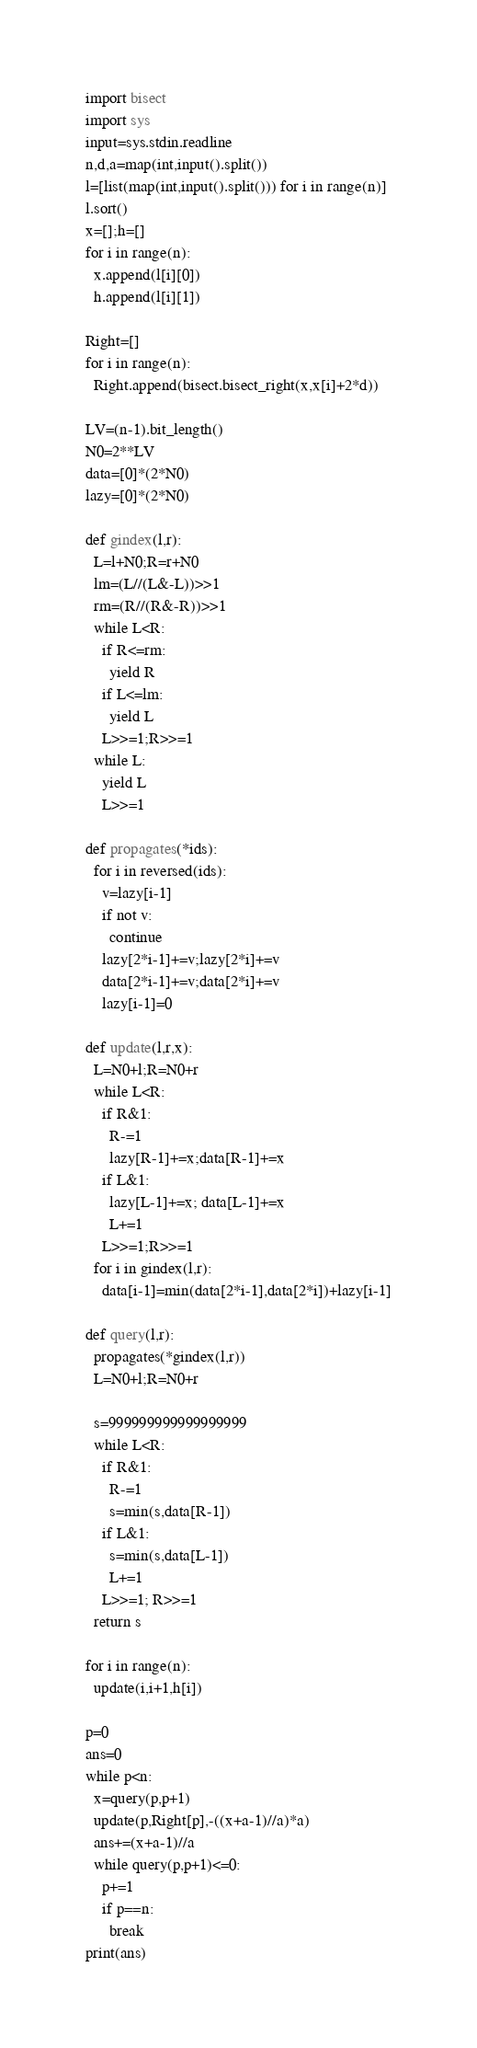<code> <loc_0><loc_0><loc_500><loc_500><_Python_>import bisect
import sys
input=sys.stdin.readline
n,d,a=map(int,input().split())
l=[list(map(int,input().split())) for i in range(n)]
l.sort()
x=[];h=[]
for i in range(n):
  x.append(l[i][0])
  h.append(l[i][1])

Right=[]
for i in range(n):
  Right.append(bisect.bisect_right(x,x[i]+2*d))

LV=(n-1).bit_length()
N0=2**LV
data=[0]*(2*N0)
lazy=[0]*(2*N0)

def gindex(l,r):
  L=l+N0;R=r+N0
  lm=(L//(L&-L))>>1
  rm=(R//(R&-R))>>1
  while L<R:
    if R<=rm:
      yield R
    if L<=lm:
      yield L
    L>>=1;R>>=1
  while L:
    yield L
    L>>=1

def propagates(*ids):
  for i in reversed(ids):
    v=lazy[i-1]
    if not v:
      continue
    lazy[2*i-1]+=v;lazy[2*i]+=v
    data[2*i-1]+=v;data[2*i]+=v
    lazy[i-1]=0

def update(l,r,x):
  L=N0+l;R=N0+r
  while L<R:
    if R&1:
      R-=1
      lazy[R-1]+=x;data[R-1]+=x
    if L&1:
      lazy[L-1]+=x; data[L-1]+=x
      L+=1
    L>>=1;R>>=1
  for i in gindex(l,r):
    data[i-1]=min(data[2*i-1],data[2*i])+lazy[i-1]

def query(l,r):
  propagates(*gindex(l,r))
  L=N0+l;R=N0+r

  s=999999999999999999
  while L<R:
    if R&1:
      R-=1
      s=min(s,data[R-1])
    if L&1:
      s=min(s,data[L-1])
      L+=1
    L>>=1; R>>=1
  return s

for i in range(n):
  update(i,i+1,h[i])

p=0
ans=0
while p<n:
  x=query(p,p+1)
  update(p,Right[p],-((x+a-1)//a)*a)
  ans+=(x+a-1)//a
  while query(p,p+1)<=0:
    p+=1
    if p==n:
      break
print(ans)</code> 